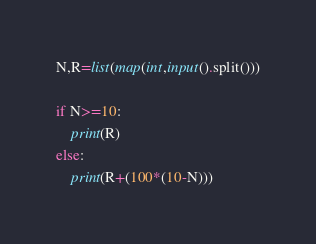Convert code to text. <code><loc_0><loc_0><loc_500><loc_500><_Python_>N,R=list(map(int,input().split()))

if N>=10:
    print(R)
else:
    print(R+(100*(10-N)))</code> 